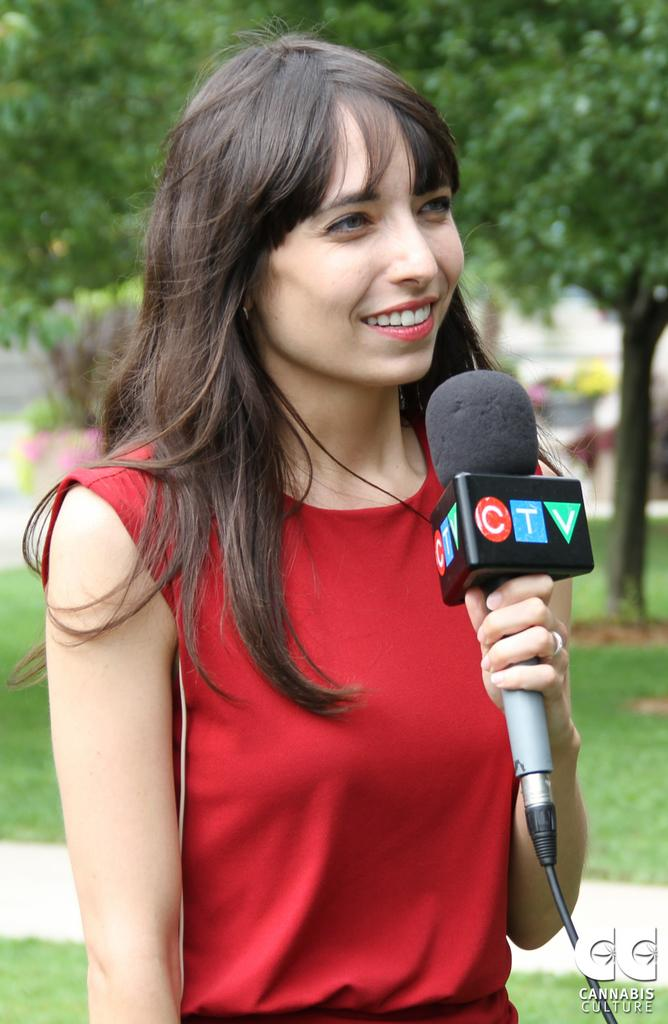What is the main subject of the image? The main subject of the image is a woman. What is the woman doing in the image? The woman is standing and talking into a microphone. What is the woman's facial expression in the image? The woman is smiling in the image. What is the woman wearing in the image? The woman is wearing a red dress in the image. What can be seen in the background of the image? There are trees, grass, and a path in the background of the image. Can you see the woman playing with a ball on the seashore in the image? No, there is no seashore or ball visible in the image. The woman is standing and talking into a microphone, and the background features trees, grass, and a path. 